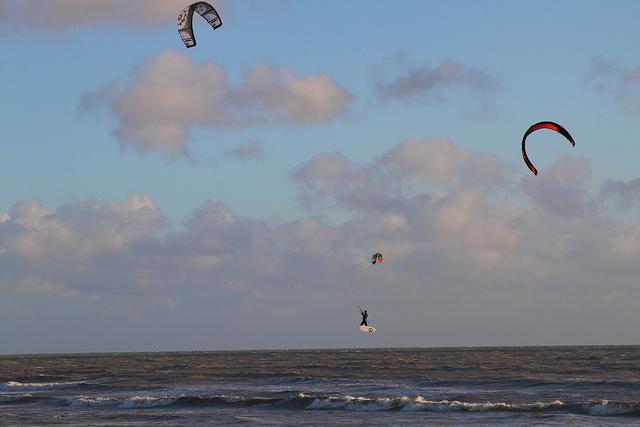Does the weather have to be just right to fly these kites?
Give a very brief answer. Yes. Who does the biggest kite belong to?
Quick response, please. Man. Is this person on the water or in the air?
Be succinct. Air. Is this a lake?
Answer briefly. No. What sport is being portrayed?
Answer briefly. Parasailing. What is the person doing?
Concise answer only. Kitesurfing. Is this scene on a beach?
Short answer required. Yes. What is flying up?
Keep it brief. Kite. How is the weather in this scene?
Keep it brief. Windy. 